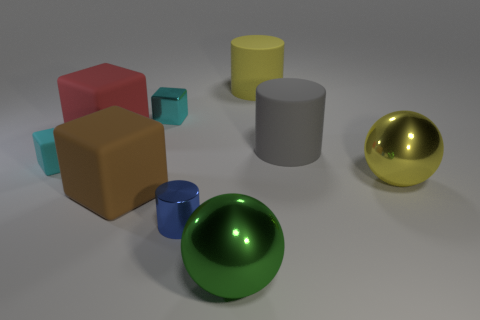There is a small rubber object; is it the same color as the small cube that is right of the tiny rubber cube?
Your answer should be very brief. Yes. How many red objects are big rubber objects or balls?
Give a very brief answer. 1. What shape is the brown rubber object?
Give a very brief answer. Cube. How many other objects are there of the same shape as the small cyan rubber thing?
Offer a very short reply. 3. What is the color of the metallic thing that is behind the cyan rubber object?
Your response must be concise. Cyan. Are the big gray thing and the red object made of the same material?
Offer a very short reply. Yes. How many objects are gray rubber things or small cubes to the left of the large brown block?
Provide a succinct answer. 2. There is a shiny cube that is the same color as the small rubber block; what is its size?
Give a very brief answer. Small. There is a large yellow thing in front of the cyan metallic thing; what is its shape?
Your answer should be compact. Sphere. There is a object that is in front of the small blue metal cylinder; does it have the same color as the small shiny cylinder?
Ensure brevity in your answer.  No. 